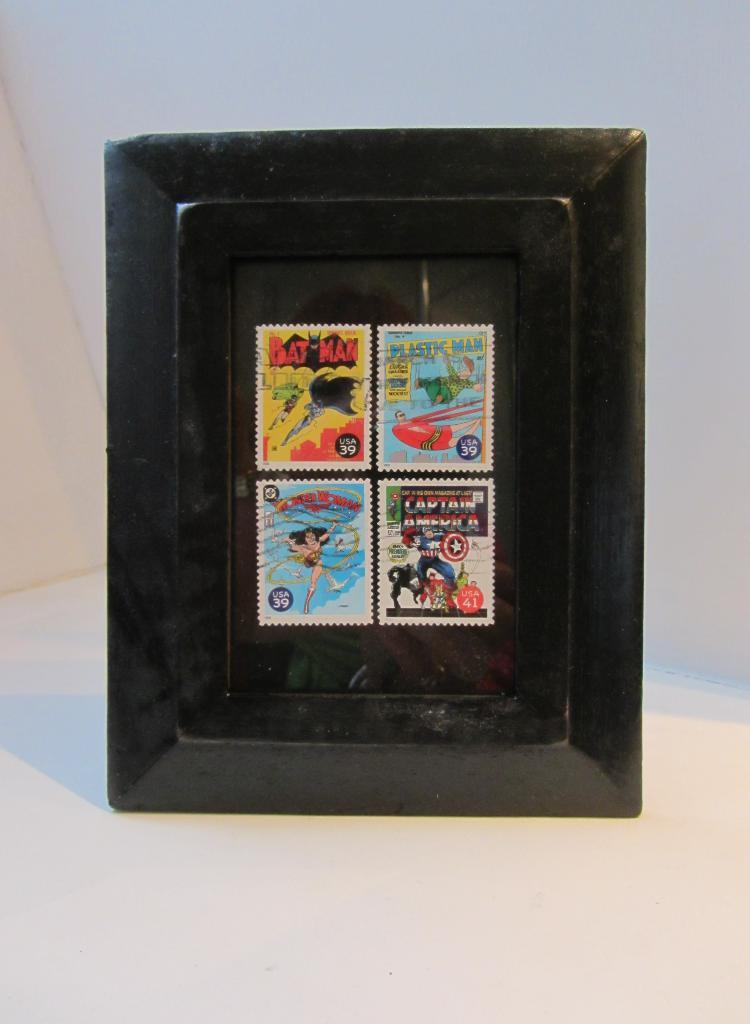<image>
Offer a succinct explanation of the picture presented. Screen showing a stamp that says Bat Man. 